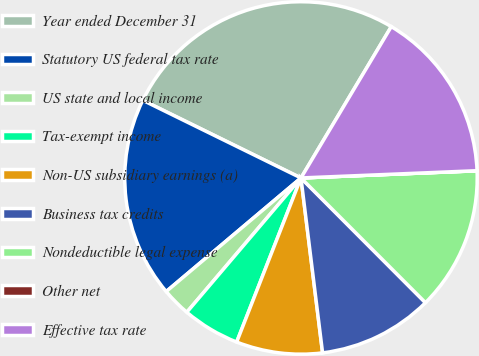Convert chart to OTSL. <chart><loc_0><loc_0><loc_500><loc_500><pie_chart><fcel>Year ended December 31<fcel>Statutory US federal tax rate<fcel>US state and local income<fcel>Tax-exempt income<fcel>Non-US subsidiary earnings (a)<fcel>Business tax credits<fcel>Nondeductible legal expense<fcel>Other net<fcel>Effective tax rate<nl><fcel>26.3%<fcel>18.41%<fcel>2.64%<fcel>5.27%<fcel>7.9%<fcel>10.53%<fcel>13.16%<fcel>0.01%<fcel>15.78%<nl></chart> 